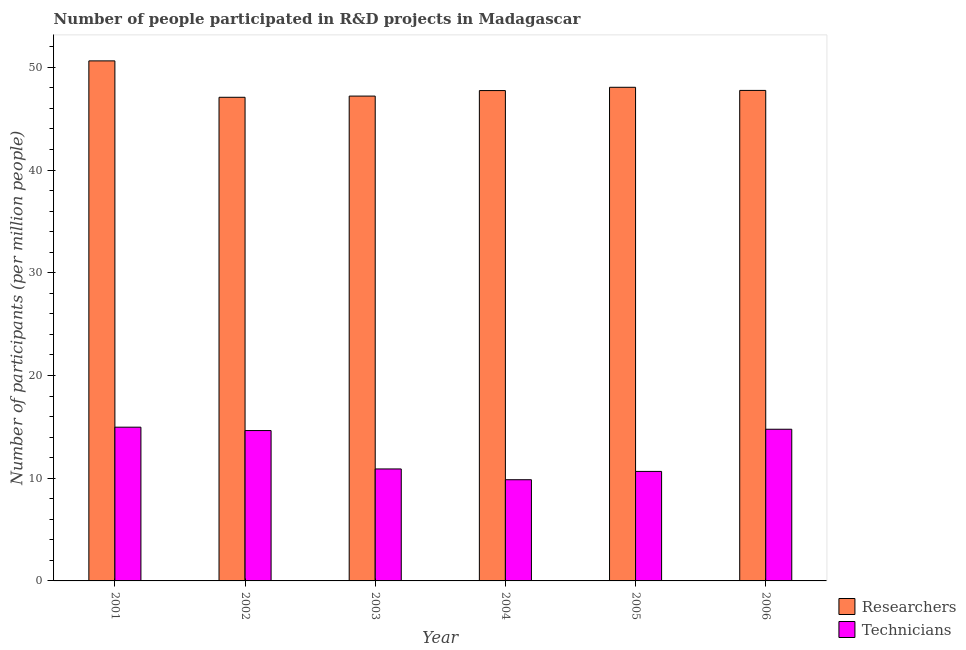How many groups of bars are there?
Your response must be concise. 6. Are the number of bars per tick equal to the number of legend labels?
Your response must be concise. Yes. Are the number of bars on each tick of the X-axis equal?
Provide a succinct answer. Yes. How many bars are there on the 5th tick from the right?
Give a very brief answer. 2. What is the number of researchers in 2001?
Your answer should be compact. 50.63. Across all years, what is the maximum number of technicians?
Make the answer very short. 14.97. Across all years, what is the minimum number of researchers?
Your answer should be very brief. 47.08. In which year was the number of researchers maximum?
Your response must be concise. 2001. What is the total number of researchers in the graph?
Your answer should be compact. 288.46. What is the difference between the number of technicians in 2003 and that in 2004?
Offer a terse response. 1.05. What is the difference between the number of researchers in 2003 and the number of technicians in 2006?
Offer a terse response. -0.55. What is the average number of researchers per year?
Your answer should be compact. 48.08. In the year 2006, what is the difference between the number of researchers and number of technicians?
Provide a short and direct response. 0. In how many years, is the number of technicians greater than 30?
Keep it short and to the point. 0. What is the ratio of the number of technicians in 2001 to that in 2002?
Your answer should be very brief. 1.02. What is the difference between the highest and the second highest number of researchers?
Keep it short and to the point. 2.57. What is the difference between the highest and the lowest number of technicians?
Your answer should be compact. 5.12. What does the 2nd bar from the left in 2006 represents?
Keep it short and to the point. Technicians. What does the 2nd bar from the right in 2006 represents?
Offer a very short reply. Researchers. How many bars are there?
Your answer should be compact. 12. Are all the bars in the graph horizontal?
Provide a short and direct response. No. How many years are there in the graph?
Provide a short and direct response. 6. Are the values on the major ticks of Y-axis written in scientific E-notation?
Keep it short and to the point. No. Does the graph contain any zero values?
Provide a short and direct response. No. Does the graph contain grids?
Provide a succinct answer. No. Where does the legend appear in the graph?
Your answer should be compact. Bottom right. How many legend labels are there?
Your response must be concise. 2. What is the title of the graph?
Ensure brevity in your answer.  Number of people participated in R&D projects in Madagascar. What is the label or title of the X-axis?
Your answer should be very brief. Year. What is the label or title of the Y-axis?
Your answer should be compact. Number of participants (per million people). What is the Number of participants (per million people) of Researchers in 2001?
Offer a very short reply. 50.63. What is the Number of participants (per million people) of Technicians in 2001?
Make the answer very short. 14.97. What is the Number of participants (per million people) in Researchers in 2002?
Keep it short and to the point. 47.08. What is the Number of participants (per million people) of Technicians in 2002?
Ensure brevity in your answer.  14.64. What is the Number of participants (per million people) of Researchers in 2003?
Your response must be concise. 47.2. What is the Number of participants (per million people) of Technicians in 2003?
Keep it short and to the point. 10.9. What is the Number of participants (per million people) in Researchers in 2004?
Offer a very short reply. 47.74. What is the Number of participants (per million people) of Technicians in 2004?
Provide a short and direct response. 9.85. What is the Number of participants (per million people) in Researchers in 2005?
Your answer should be compact. 48.06. What is the Number of participants (per million people) of Technicians in 2005?
Keep it short and to the point. 10.66. What is the Number of participants (per million people) in Researchers in 2006?
Give a very brief answer. 47.75. What is the Number of participants (per million people) of Technicians in 2006?
Provide a succinct answer. 14.77. Across all years, what is the maximum Number of participants (per million people) of Researchers?
Provide a succinct answer. 50.63. Across all years, what is the maximum Number of participants (per million people) of Technicians?
Keep it short and to the point. 14.97. Across all years, what is the minimum Number of participants (per million people) of Researchers?
Provide a succinct answer. 47.08. Across all years, what is the minimum Number of participants (per million people) in Technicians?
Offer a very short reply. 9.85. What is the total Number of participants (per million people) of Researchers in the graph?
Your answer should be compact. 288.46. What is the total Number of participants (per million people) of Technicians in the graph?
Your answer should be compact. 75.79. What is the difference between the Number of participants (per million people) of Researchers in 2001 and that in 2002?
Provide a succinct answer. 3.54. What is the difference between the Number of participants (per million people) in Technicians in 2001 and that in 2002?
Ensure brevity in your answer.  0.33. What is the difference between the Number of participants (per million people) of Researchers in 2001 and that in 2003?
Offer a very short reply. 3.43. What is the difference between the Number of participants (per million people) of Technicians in 2001 and that in 2003?
Offer a terse response. 4.07. What is the difference between the Number of participants (per million people) in Researchers in 2001 and that in 2004?
Offer a very short reply. 2.89. What is the difference between the Number of participants (per million people) in Technicians in 2001 and that in 2004?
Offer a very short reply. 5.12. What is the difference between the Number of participants (per million people) in Researchers in 2001 and that in 2005?
Offer a terse response. 2.57. What is the difference between the Number of participants (per million people) in Technicians in 2001 and that in 2005?
Give a very brief answer. 4.31. What is the difference between the Number of participants (per million people) of Researchers in 2001 and that in 2006?
Your response must be concise. 2.88. What is the difference between the Number of participants (per million people) in Technicians in 2001 and that in 2006?
Keep it short and to the point. 0.2. What is the difference between the Number of participants (per million people) in Researchers in 2002 and that in 2003?
Give a very brief answer. -0.12. What is the difference between the Number of participants (per million people) in Technicians in 2002 and that in 2003?
Offer a very short reply. 3.74. What is the difference between the Number of participants (per million people) in Researchers in 2002 and that in 2004?
Offer a terse response. -0.65. What is the difference between the Number of participants (per million people) of Technicians in 2002 and that in 2004?
Keep it short and to the point. 4.79. What is the difference between the Number of participants (per million people) in Researchers in 2002 and that in 2005?
Keep it short and to the point. -0.97. What is the difference between the Number of participants (per million people) of Technicians in 2002 and that in 2005?
Keep it short and to the point. 3.98. What is the difference between the Number of participants (per million people) in Researchers in 2002 and that in 2006?
Keep it short and to the point. -0.67. What is the difference between the Number of participants (per million people) in Technicians in 2002 and that in 2006?
Keep it short and to the point. -0.13. What is the difference between the Number of participants (per million people) in Researchers in 2003 and that in 2004?
Offer a very short reply. -0.54. What is the difference between the Number of participants (per million people) in Technicians in 2003 and that in 2004?
Your answer should be compact. 1.05. What is the difference between the Number of participants (per million people) in Researchers in 2003 and that in 2005?
Keep it short and to the point. -0.86. What is the difference between the Number of participants (per million people) in Technicians in 2003 and that in 2005?
Keep it short and to the point. 0.24. What is the difference between the Number of participants (per million people) of Researchers in 2003 and that in 2006?
Ensure brevity in your answer.  -0.55. What is the difference between the Number of participants (per million people) in Technicians in 2003 and that in 2006?
Give a very brief answer. -3.87. What is the difference between the Number of participants (per million people) in Researchers in 2004 and that in 2005?
Keep it short and to the point. -0.32. What is the difference between the Number of participants (per million people) in Technicians in 2004 and that in 2005?
Your answer should be compact. -0.81. What is the difference between the Number of participants (per million people) of Researchers in 2004 and that in 2006?
Ensure brevity in your answer.  -0.01. What is the difference between the Number of participants (per million people) of Technicians in 2004 and that in 2006?
Ensure brevity in your answer.  -4.92. What is the difference between the Number of participants (per million people) of Researchers in 2005 and that in 2006?
Ensure brevity in your answer.  0.31. What is the difference between the Number of participants (per million people) of Technicians in 2005 and that in 2006?
Offer a very short reply. -4.11. What is the difference between the Number of participants (per million people) in Researchers in 2001 and the Number of participants (per million people) in Technicians in 2002?
Provide a short and direct response. 35.99. What is the difference between the Number of participants (per million people) in Researchers in 2001 and the Number of participants (per million people) in Technicians in 2003?
Your response must be concise. 39.73. What is the difference between the Number of participants (per million people) in Researchers in 2001 and the Number of participants (per million people) in Technicians in 2004?
Provide a short and direct response. 40.78. What is the difference between the Number of participants (per million people) of Researchers in 2001 and the Number of participants (per million people) of Technicians in 2005?
Your answer should be compact. 39.97. What is the difference between the Number of participants (per million people) of Researchers in 2001 and the Number of participants (per million people) of Technicians in 2006?
Ensure brevity in your answer.  35.86. What is the difference between the Number of participants (per million people) in Researchers in 2002 and the Number of participants (per million people) in Technicians in 2003?
Provide a succinct answer. 36.18. What is the difference between the Number of participants (per million people) in Researchers in 2002 and the Number of participants (per million people) in Technicians in 2004?
Offer a terse response. 37.23. What is the difference between the Number of participants (per million people) of Researchers in 2002 and the Number of participants (per million people) of Technicians in 2005?
Your answer should be compact. 36.42. What is the difference between the Number of participants (per million people) of Researchers in 2002 and the Number of participants (per million people) of Technicians in 2006?
Provide a succinct answer. 32.32. What is the difference between the Number of participants (per million people) of Researchers in 2003 and the Number of participants (per million people) of Technicians in 2004?
Provide a short and direct response. 37.35. What is the difference between the Number of participants (per million people) in Researchers in 2003 and the Number of participants (per million people) in Technicians in 2005?
Ensure brevity in your answer.  36.54. What is the difference between the Number of participants (per million people) in Researchers in 2003 and the Number of participants (per million people) in Technicians in 2006?
Your answer should be very brief. 32.43. What is the difference between the Number of participants (per million people) in Researchers in 2004 and the Number of participants (per million people) in Technicians in 2005?
Provide a succinct answer. 37.08. What is the difference between the Number of participants (per million people) in Researchers in 2004 and the Number of participants (per million people) in Technicians in 2006?
Provide a succinct answer. 32.97. What is the difference between the Number of participants (per million people) of Researchers in 2005 and the Number of participants (per million people) of Technicians in 2006?
Your response must be concise. 33.29. What is the average Number of participants (per million people) of Researchers per year?
Give a very brief answer. 48.08. What is the average Number of participants (per million people) of Technicians per year?
Provide a succinct answer. 12.63. In the year 2001, what is the difference between the Number of participants (per million people) of Researchers and Number of participants (per million people) of Technicians?
Provide a succinct answer. 35.66. In the year 2002, what is the difference between the Number of participants (per million people) in Researchers and Number of participants (per million people) in Technicians?
Offer a very short reply. 32.45. In the year 2003, what is the difference between the Number of participants (per million people) of Researchers and Number of participants (per million people) of Technicians?
Make the answer very short. 36.3. In the year 2004, what is the difference between the Number of participants (per million people) in Researchers and Number of participants (per million people) in Technicians?
Make the answer very short. 37.89. In the year 2005, what is the difference between the Number of participants (per million people) in Researchers and Number of participants (per million people) in Technicians?
Your response must be concise. 37.4. In the year 2006, what is the difference between the Number of participants (per million people) of Researchers and Number of participants (per million people) of Technicians?
Make the answer very short. 32.99. What is the ratio of the Number of participants (per million people) in Researchers in 2001 to that in 2002?
Your response must be concise. 1.08. What is the ratio of the Number of participants (per million people) of Technicians in 2001 to that in 2002?
Offer a terse response. 1.02. What is the ratio of the Number of participants (per million people) in Researchers in 2001 to that in 2003?
Ensure brevity in your answer.  1.07. What is the ratio of the Number of participants (per million people) in Technicians in 2001 to that in 2003?
Provide a succinct answer. 1.37. What is the ratio of the Number of participants (per million people) of Researchers in 2001 to that in 2004?
Keep it short and to the point. 1.06. What is the ratio of the Number of participants (per million people) in Technicians in 2001 to that in 2004?
Ensure brevity in your answer.  1.52. What is the ratio of the Number of participants (per million people) in Researchers in 2001 to that in 2005?
Your response must be concise. 1.05. What is the ratio of the Number of participants (per million people) of Technicians in 2001 to that in 2005?
Offer a very short reply. 1.4. What is the ratio of the Number of participants (per million people) of Researchers in 2001 to that in 2006?
Give a very brief answer. 1.06. What is the ratio of the Number of participants (per million people) of Technicians in 2001 to that in 2006?
Your answer should be compact. 1.01. What is the ratio of the Number of participants (per million people) of Researchers in 2002 to that in 2003?
Provide a succinct answer. 1. What is the ratio of the Number of participants (per million people) in Technicians in 2002 to that in 2003?
Give a very brief answer. 1.34. What is the ratio of the Number of participants (per million people) in Researchers in 2002 to that in 2004?
Your response must be concise. 0.99. What is the ratio of the Number of participants (per million people) in Technicians in 2002 to that in 2004?
Provide a short and direct response. 1.49. What is the ratio of the Number of participants (per million people) in Researchers in 2002 to that in 2005?
Your answer should be very brief. 0.98. What is the ratio of the Number of participants (per million people) in Technicians in 2002 to that in 2005?
Give a very brief answer. 1.37. What is the ratio of the Number of participants (per million people) in Technicians in 2002 to that in 2006?
Your response must be concise. 0.99. What is the ratio of the Number of participants (per million people) in Researchers in 2003 to that in 2004?
Your response must be concise. 0.99. What is the ratio of the Number of participants (per million people) in Technicians in 2003 to that in 2004?
Give a very brief answer. 1.11. What is the ratio of the Number of participants (per million people) of Researchers in 2003 to that in 2005?
Provide a short and direct response. 0.98. What is the ratio of the Number of participants (per million people) in Technicians in 2003 to that in 2005?
Your answer should be compact. 1.02. What is the ratio of the Number of participants (per million people) of Researchers in 2003 to that in 2006?
Keep it short and to the point. 0.99. What is the ratio of the Number of participants (per million people) of Technicians in 2003 to that in 2006?
Your answer should be very brief. 0.74. What is the ratio of the Number of participants (per million people) in Researchers in 2004 to that in 2005?
Your response must be concise. 0.99. What is the ratio of the Number of participants (per million people) of Technicians in 2004 to that in 2005?
Give a very brief answer. 0.92. What is the ratio of the Number of participants (per million people) of Technicians in 2004 to that in 2006?
Offer a very short reply. 0.67. What is the ratio of the Number of participants (per million people) of Researchers in 2005 to that in 2006?
Give a very brief answer. 1.01. What is the ratio of the Number of participants (per million people) of Technicians in 2005 to that in 2006?
Provide a succinct answer. 0.72. What is the difference between the highest and the second highest Number of participants (per million people) of Researchers?
Make the answer very short. 2.57. What is the difference between the highest and the second highest Number of participants (per million people) in Technicians?
Keep it short and to the point. 0.2. What is the difference between the highest and the lowest Number of participants (per million people) in Researchers?
Ensure brevity in your answer.  3.54. What is the difference between the highest and the lowest Number of participants (per million people) of Technicians?
Your answer should be very brief. 5.12. 